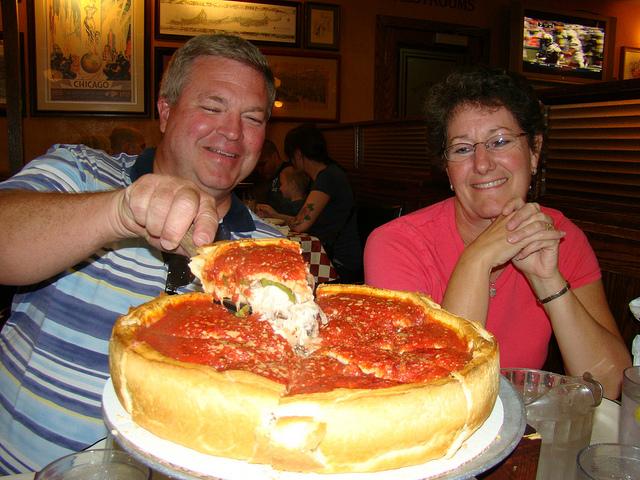Which hand is the man using to serve the food?
Quick response, please. Right. How many glasses are there?
Quick response, please. 2. What is the man doing to the pizza?
Quick response, please. Serving. What's on the TV screen?
Be succinct. Football. What utensil is on the table?
Write a very short answer. Fork. Are they happy?
Be succinct. Yes. 